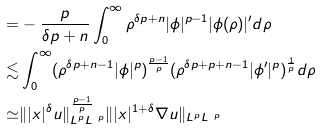Convert formula to latex. <formula><loc_0><loc_0><loc_500><loc_500>= & - \frac { p } { \delta p + n } \int _ { 0 } ^ { \infty } \rho ^ { \delta p + n } | \phi | ^ { p - 1 } | \phi ( \rho ) | ^ { \prime } d \rho \\ \lesssim & \int _ { 0 } ^ { \infty } ( \rho ^ { \delta p + n - 1 } | \phi | ^ { p } ) ^ { \frac { p - 1 } { p } } ( \rho ^ { \delta p + p + n - 1 } | \phi ^ { \prime } | ^ { p } ) ^ { \frac { 1 } { p } } d \rho \\ \simeq & \| | x | ^ { \delta } u \| ^ { \frac { p - 1 } { p } } _ { L ^ { p } L ^ { \ p } } \| | x | ^ { 1 + \delta } \nabla u \| _ { L ^ { p } L ^ { \ p } }</formula> 